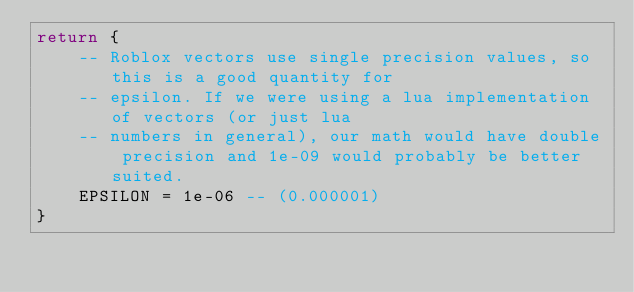Convert code to text. <code><loc_0><loc_0><loc_500><loc_500><_Lua_>return {
	-- Roblox vectors use single precision values, so this is a good quantity for
	-- epsilon. If we were using a lua implementation of vectors (or just lua
	-- numbers in general), our math would have double precision and 1e-09 would probably be better suited.
	EPSILON = 1e-06 -- (0.000001)
}
</code> 